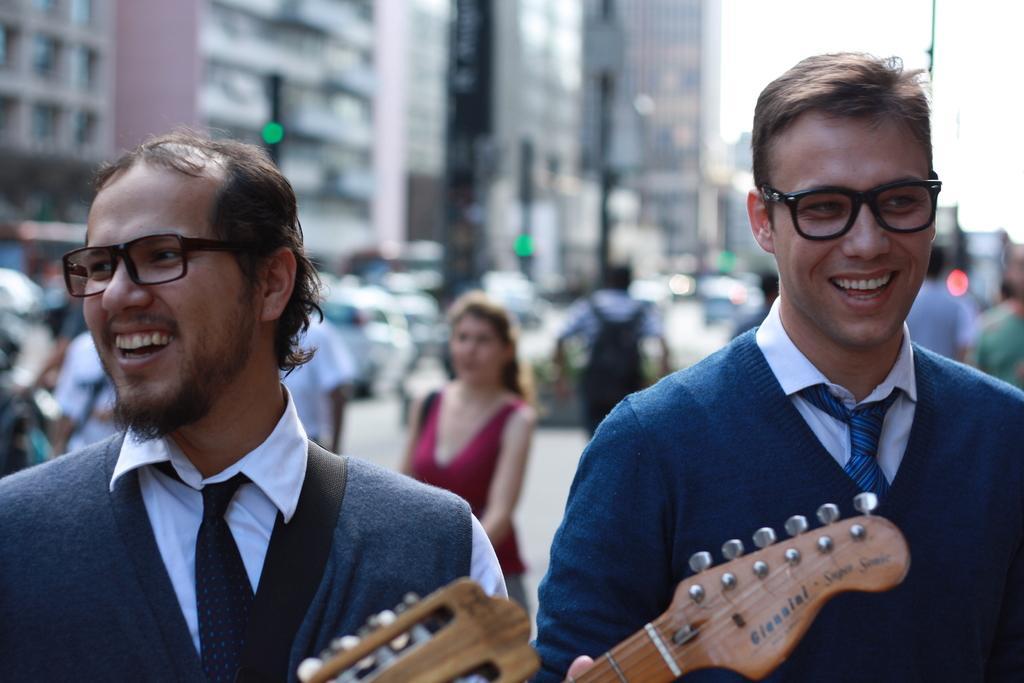Please provide a concise description of this image. This picture is of outside. On the right there is a man smiling and seems to be standing. On the left there is a man smiling, seems to be walking and holding guitar, behind him there is a woman seems to be walking. In the background we can see a group of people, cars and buildings and also the sky. 